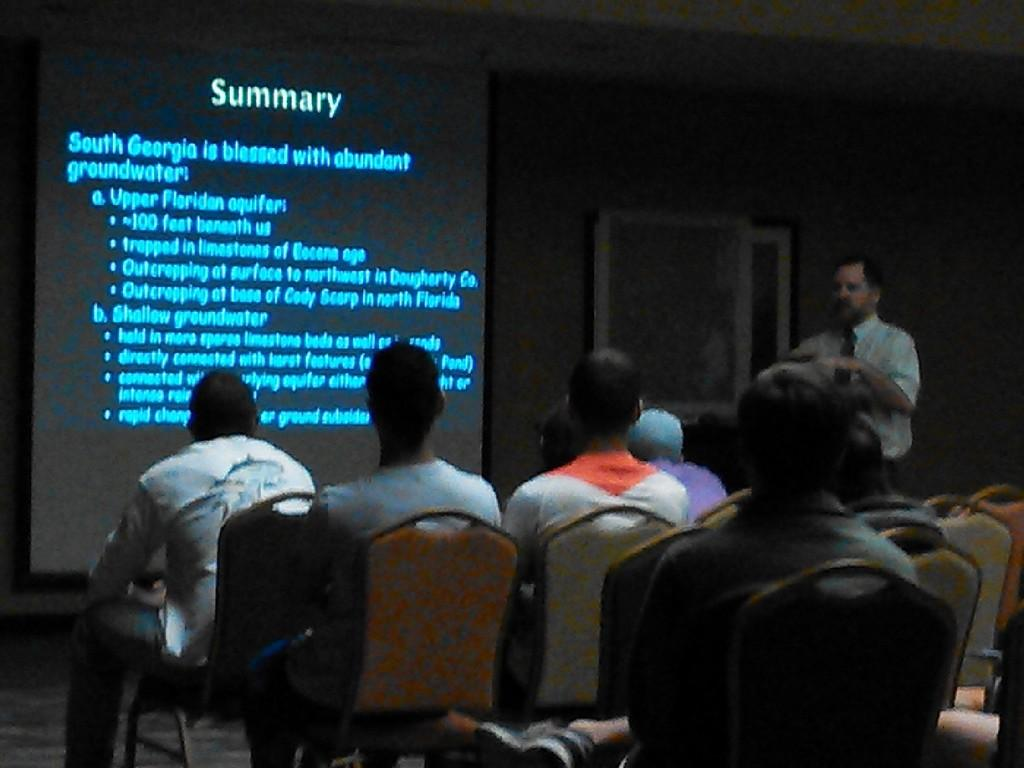What are the people in the image doing? The people in the image are sitting in chairs. Is there anyone standing in the image? Yes, there is a person standing and talking in the image. What can be seen on the board in the image? There is a display on a board in the image. What type of footwear is the person wearing while talking in the image? There is no information about the person's footwear in the image. Is there a hammer visible in the image? No, there is no hammer present in the image. 